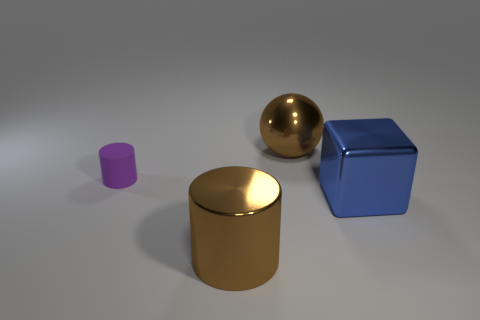Add 3 cylinders. How many objects exist? 7 Subtract all spheres. How many objects are left? 3 Subtract 0 yellow spheres. How many objects are left? 4 Subtract all tiny purple cubes. Subtract all tiny cylinders. How many objects are left? 3 Add 1 blue cubes. How many blue cubes are left? 2 Add 2 cylinders. How many cylinders exist? 4 